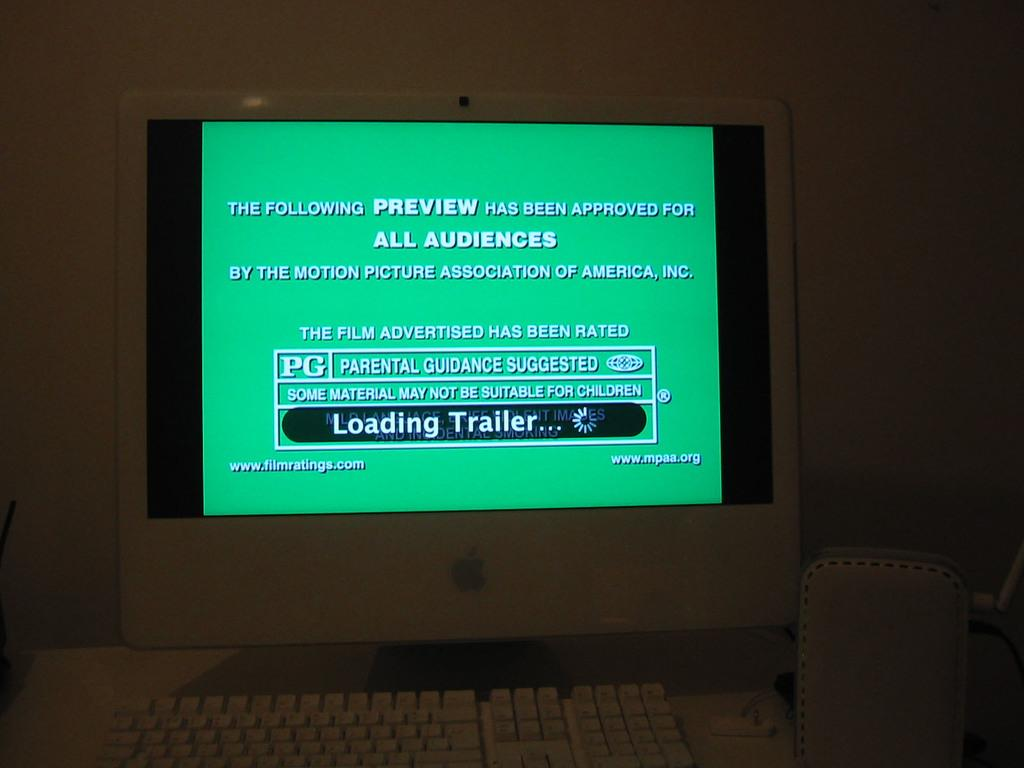<image>
Relay a brief, clear account of the picture shown. a computer monitor with a green screen and the words "Loading Trailer.." on it 